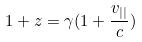<formula> <loc_0><loc_0><loc_500><loc_500>1 + z = \gamma ( 1 + \frac { v _ { | | } } { c } )</formula> 